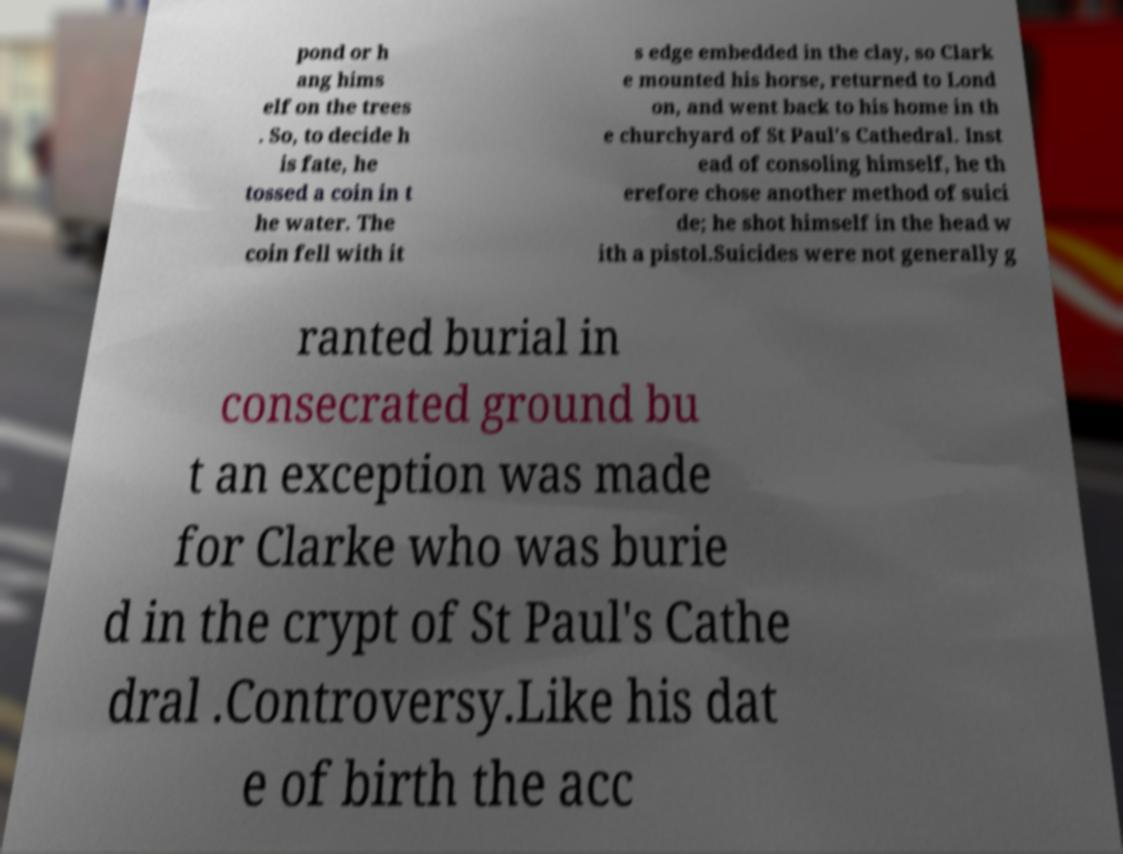What messages or text are displayed in this image? I need them in a readable, typed format. pond or h ang hims elf on the trees . So, to decide h is fate, he tossed a coin in t he water. The coin fell with it s edge embedded in the clay, so Clark e mounted his horse, returned to Lond on, and went back to his home in th e churchyard of St Paul's Cathedral. Inst ead of consoling himself, he th erefore chose another method of suici de; he shot himself in the head w ith a pistol.Suicides were not generally g ranted burial in consecrated ground bu t an exception was made for Clarke who was burie d in the crypt of St Paul's Cathe dral .Controversy.Like his dat e of birth the acc 